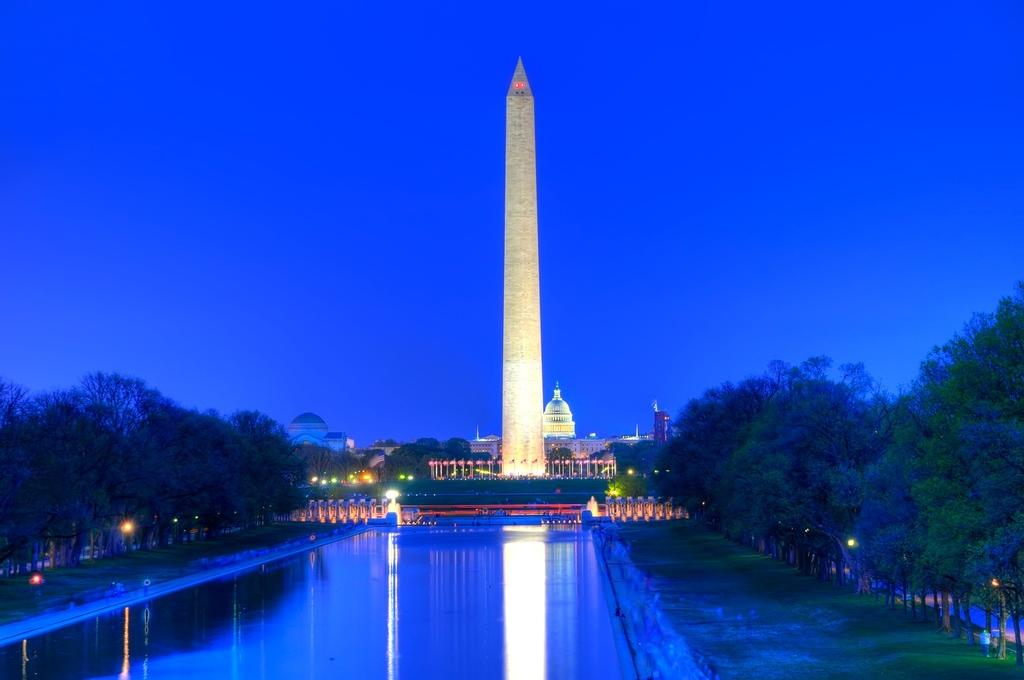What is visible in the image? There is water, trees, lights, a tower, buildings, and a blue sky visible in the image. What type of vegetation can be seen in the background? There are trees in the background of the image. What architectural feature is present in the image? There is a tower in the image. What is the color of the sky in the image? The sky is blue in color. What type of apparel is being worn by the river in the image? There is no river present in the image, and therefore no apparel can be associated with it. How many additions were made to the image after it was initially created? The provided facts do not mention any additions to the image, so it cannot be determined from the information given. 